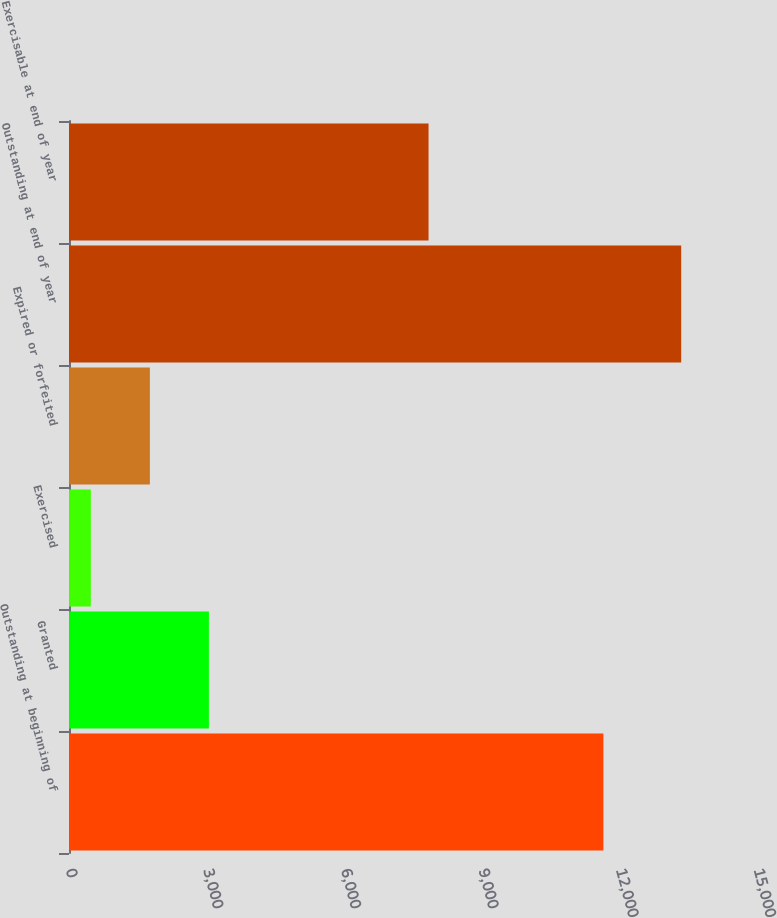<chart> <loc_0><loc_0><loc_500><loc_500><bar_chart><fcel>Outstanding at beginning of<fcel>Granted<fcel>Exercised<fcel>Expired or forfeited<fcel>Outstanding at end of year<fcel>Exercisable at end of year<nl><fcel>11651<fcel>3050.2<fcel>476<fcel>1763.1<fcel>13347<fcel>7839<nl></chart> 